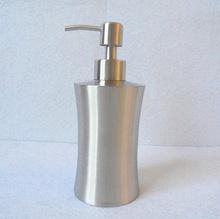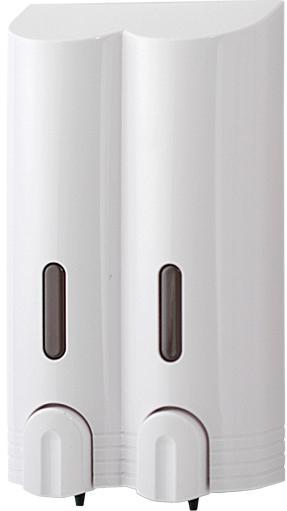The first image is the image on the left, the second image is the image on the right. For the images displayed, is the sentence "Exactly three wall mounted bathroom dispensers are shown, with two matching dispensers in one image and different third dispenser in the other image." factually correct? Answer yes or no. No. 